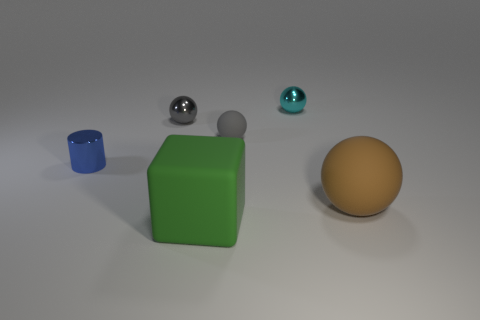How big is the thing that is to the right of the small rubber sphere and behind the large brown ball?
Offer a very short reply. Small. Is there a metal ball of the same size as the gray matte ball?
Give a very brief answer. Yes. Are there more cyan objects that are on the left side of the small gray metal thing than big brown rubber objects behind the large sphere?
Your response must be concise. No. Is the tiny cyan ball made of the same material as the tiny blue object that is in front of the tiny cyan ball?
Offer a terse response. Yes. What number of rubber balls are in front of the big matte thing left of the matte ball in front of the tiny blue thing?
Provide a short and direct response. 0. There is a cyan thing; does it have the same shape as the small metallic object that is in front of the tiny matte ball?
Keep it short and to the point. No. What color is the sphere that is left of the small cyan metal thing and to the right of the small gray metal sphere?
Your answer should be very brief. Gray. What material is the small gray thing to the left of the rubber thing in front of the rubber ball that is in front of the blue metal object?
Your answer should be compact. Metal. What material is the tiny blue cylinder?
Provide a short and direct response. Metal. There is a gray matte object that is the same shape as the cyan thing; what size is it?
Keep it short and to the point. Small. 